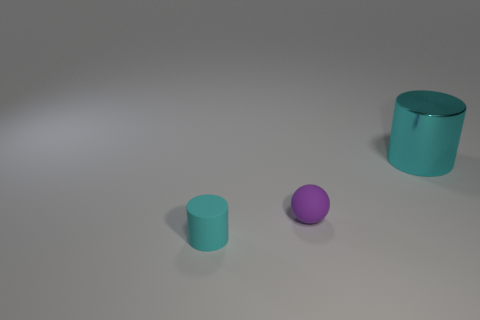Add 3 big yellow blocks. How many objects exist? 6 Subtract 2 cylinders. How many cylinders are left? 0 Subtract all cylinders. How many objects are left? 1 Add 1 large cyan cylinders. How many large cyan cylinders are left? 2 Add 2 big cyan metal cylinders. How many big cyan metal cylinders exist? 3 Subtract 0 gray spheres. How many objects are left? 3 Subtract all yellow cylinders. Subtract all green blocks. How many cylinders are left? 2 Subtract all small red shiny cubes. Subtract all tiny rubber spheres. How many objects are left? 2 